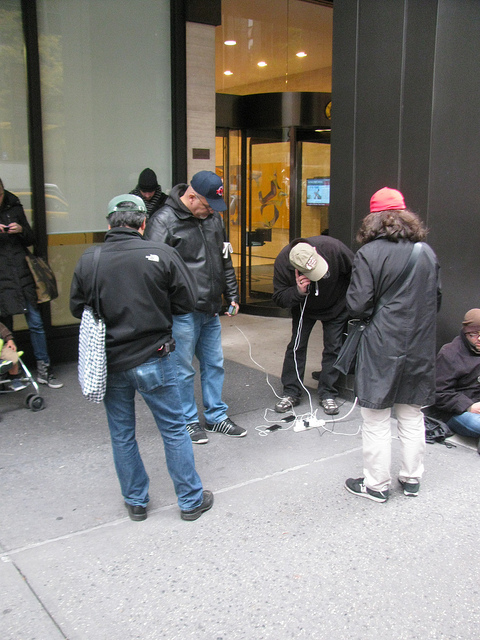Where is the bench? After another close look, it remains true that there's no bench in this image. Perhaps you're referring to another aspect of the scene? Feel free to inquire about other elements. 